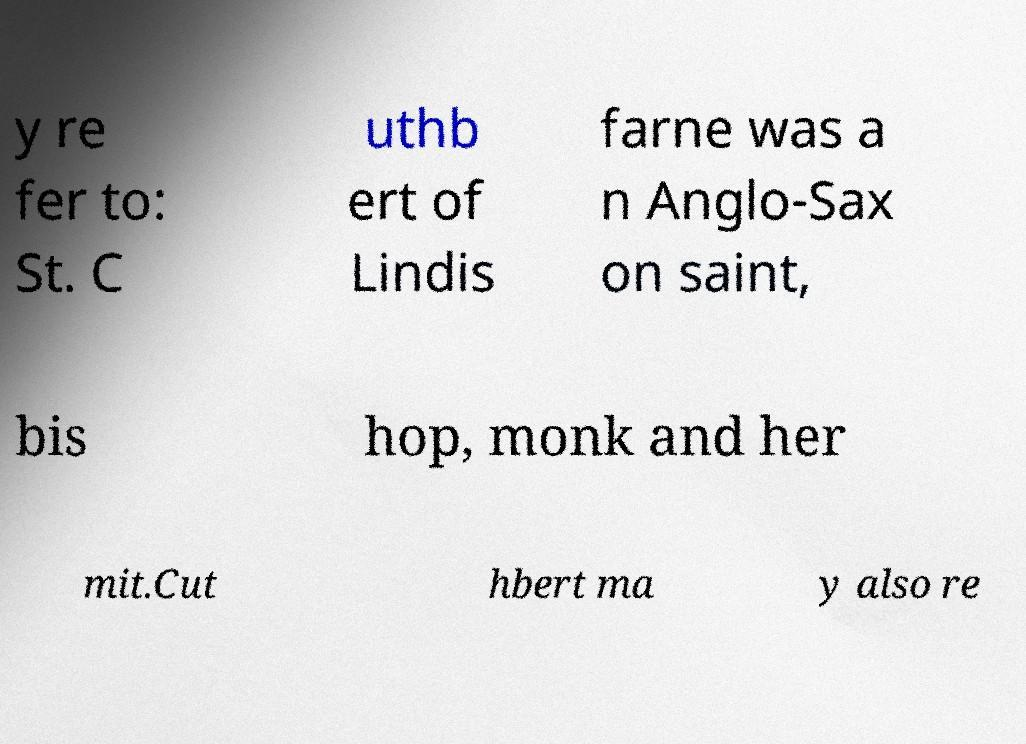Please read and relay the text visible in this image. What does it say? y re fer to: St. C uthb ert of Lindis farne was a n Anglo-Sax on saint, bis hop, monk and her mit.Cut hbert ma y also re 